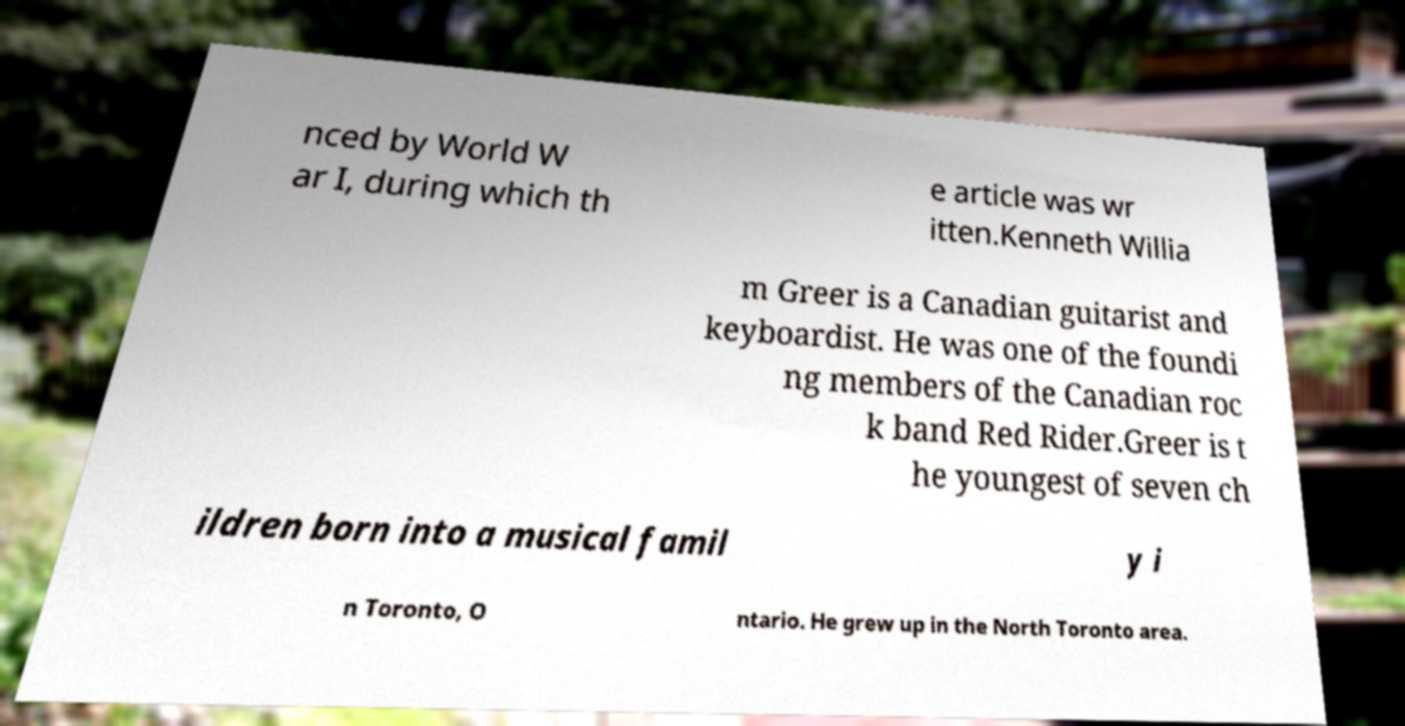I need the written content from this picture converted into text. Can you do that? nced by World W ar I, during which th e article was wr itten.Kenneth Willia m Greer is a Canadian guitarist and keyboardist. He was one of the foundi ng members of the Canadian roc k band Red Rider.Greer is t he youngest of seven ch ildren born into a musical famil y i n Toronto, O ntario. He grew up in the North Toronto area. 